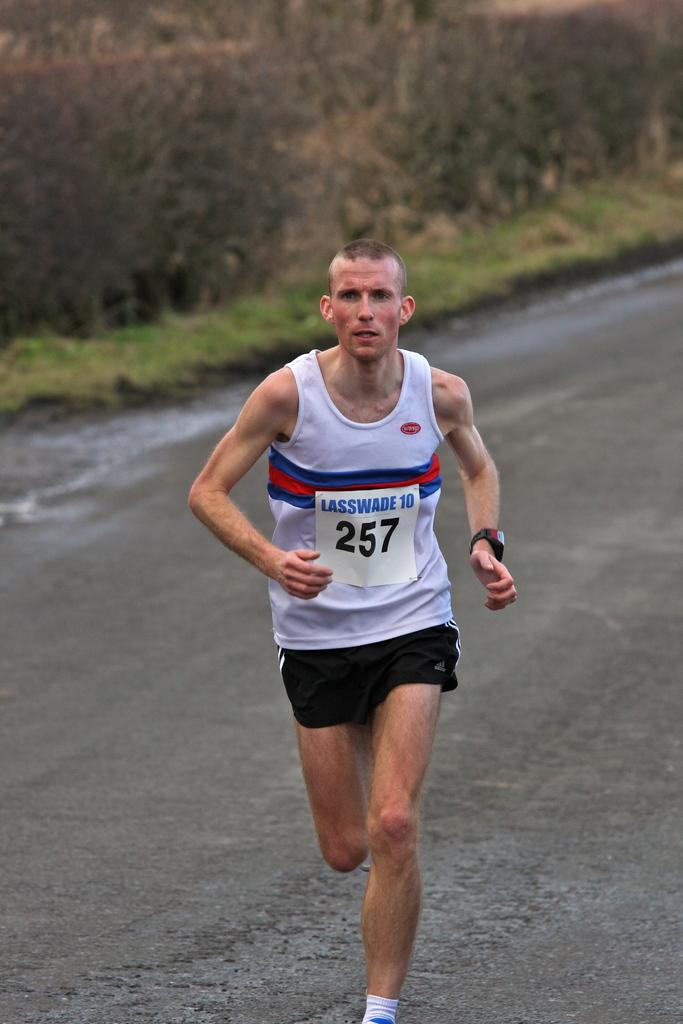<image>
Render a clear and concise summary of the photo. a man wearing the number 257 is running a race 